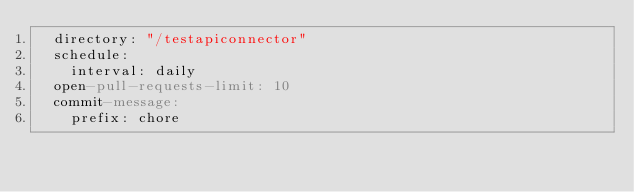Convert code to text. <code><loc_0><loc_0><loc_500><loc_500><_YAML_>  directory: "/testapiconnector"
  schedule:
    interval: daily
  open-pull-requests-limit: 10
  commit-message:
    prefix: chore
</code> 